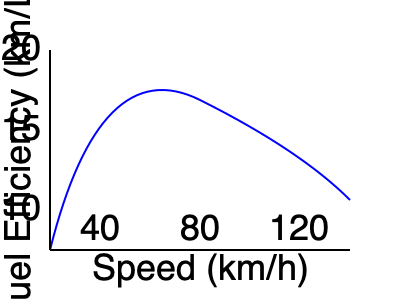As a taxi driver always in a rush, you notice that your fuel efficiency changes with speed. Based on the fuel efficiency curve shown, at approximately what speed (in km/h) would you achieve the best fuel efficiency for your taxi? To determine the speed at which the taxi achieves the best fuel efficiency, we need to analyze the given fuel efficiency curve:

1. The x-axis represents speed in km/h, while the y-axis represents fuel efficiency in km/L.
2. The curve's peak indicates the point of maximum fuel efficiency.
3. To find this peak, we need to identify the highest point on the curve.
4. Examining the graph, we can see that the curve reaches its highest point at approximately 80 km/h on the x-axis.
5. At this speed, the fuel efficiency appears to be around 18-19 km/L.
6. Before and after this point, the fuel efficiency is lower, confirming that this is indeed the optimal speed for fuel efficiency.

Therefore, the speed at which the taxi would achieve the best fuel efficiency is approximately 80 km/h.
Answer: 80 km/h 